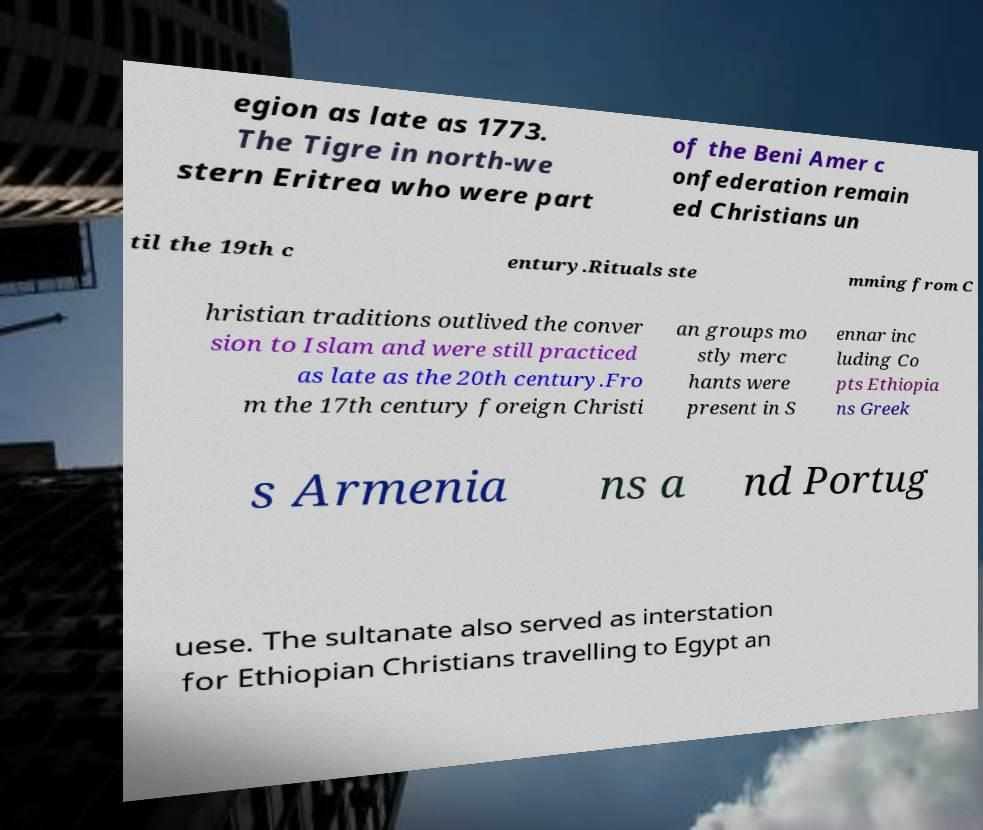Can you read and provide the text displayed in the image?This photo seems to have some interesting text. Can you extract and type it out for me? egion as late as 1773. The Tigre in north-we stern Eritrea who were part of the Beni Amer c onfederation remain ed Christians un til the 19th c entury.Rituals ste mming from C hristian traditions outlived the conver sion to Islam and were still practiced as late as the 20th century.Fro m the 17th century foreign Christi an groups mo stly merc hants were present in S ennar inc luding Co pts Ethiopia ns Greek s Armenia ns a nd Portug uese. The sultanate also served as interstation for Ethiopian Christians travelling to Egypt an 